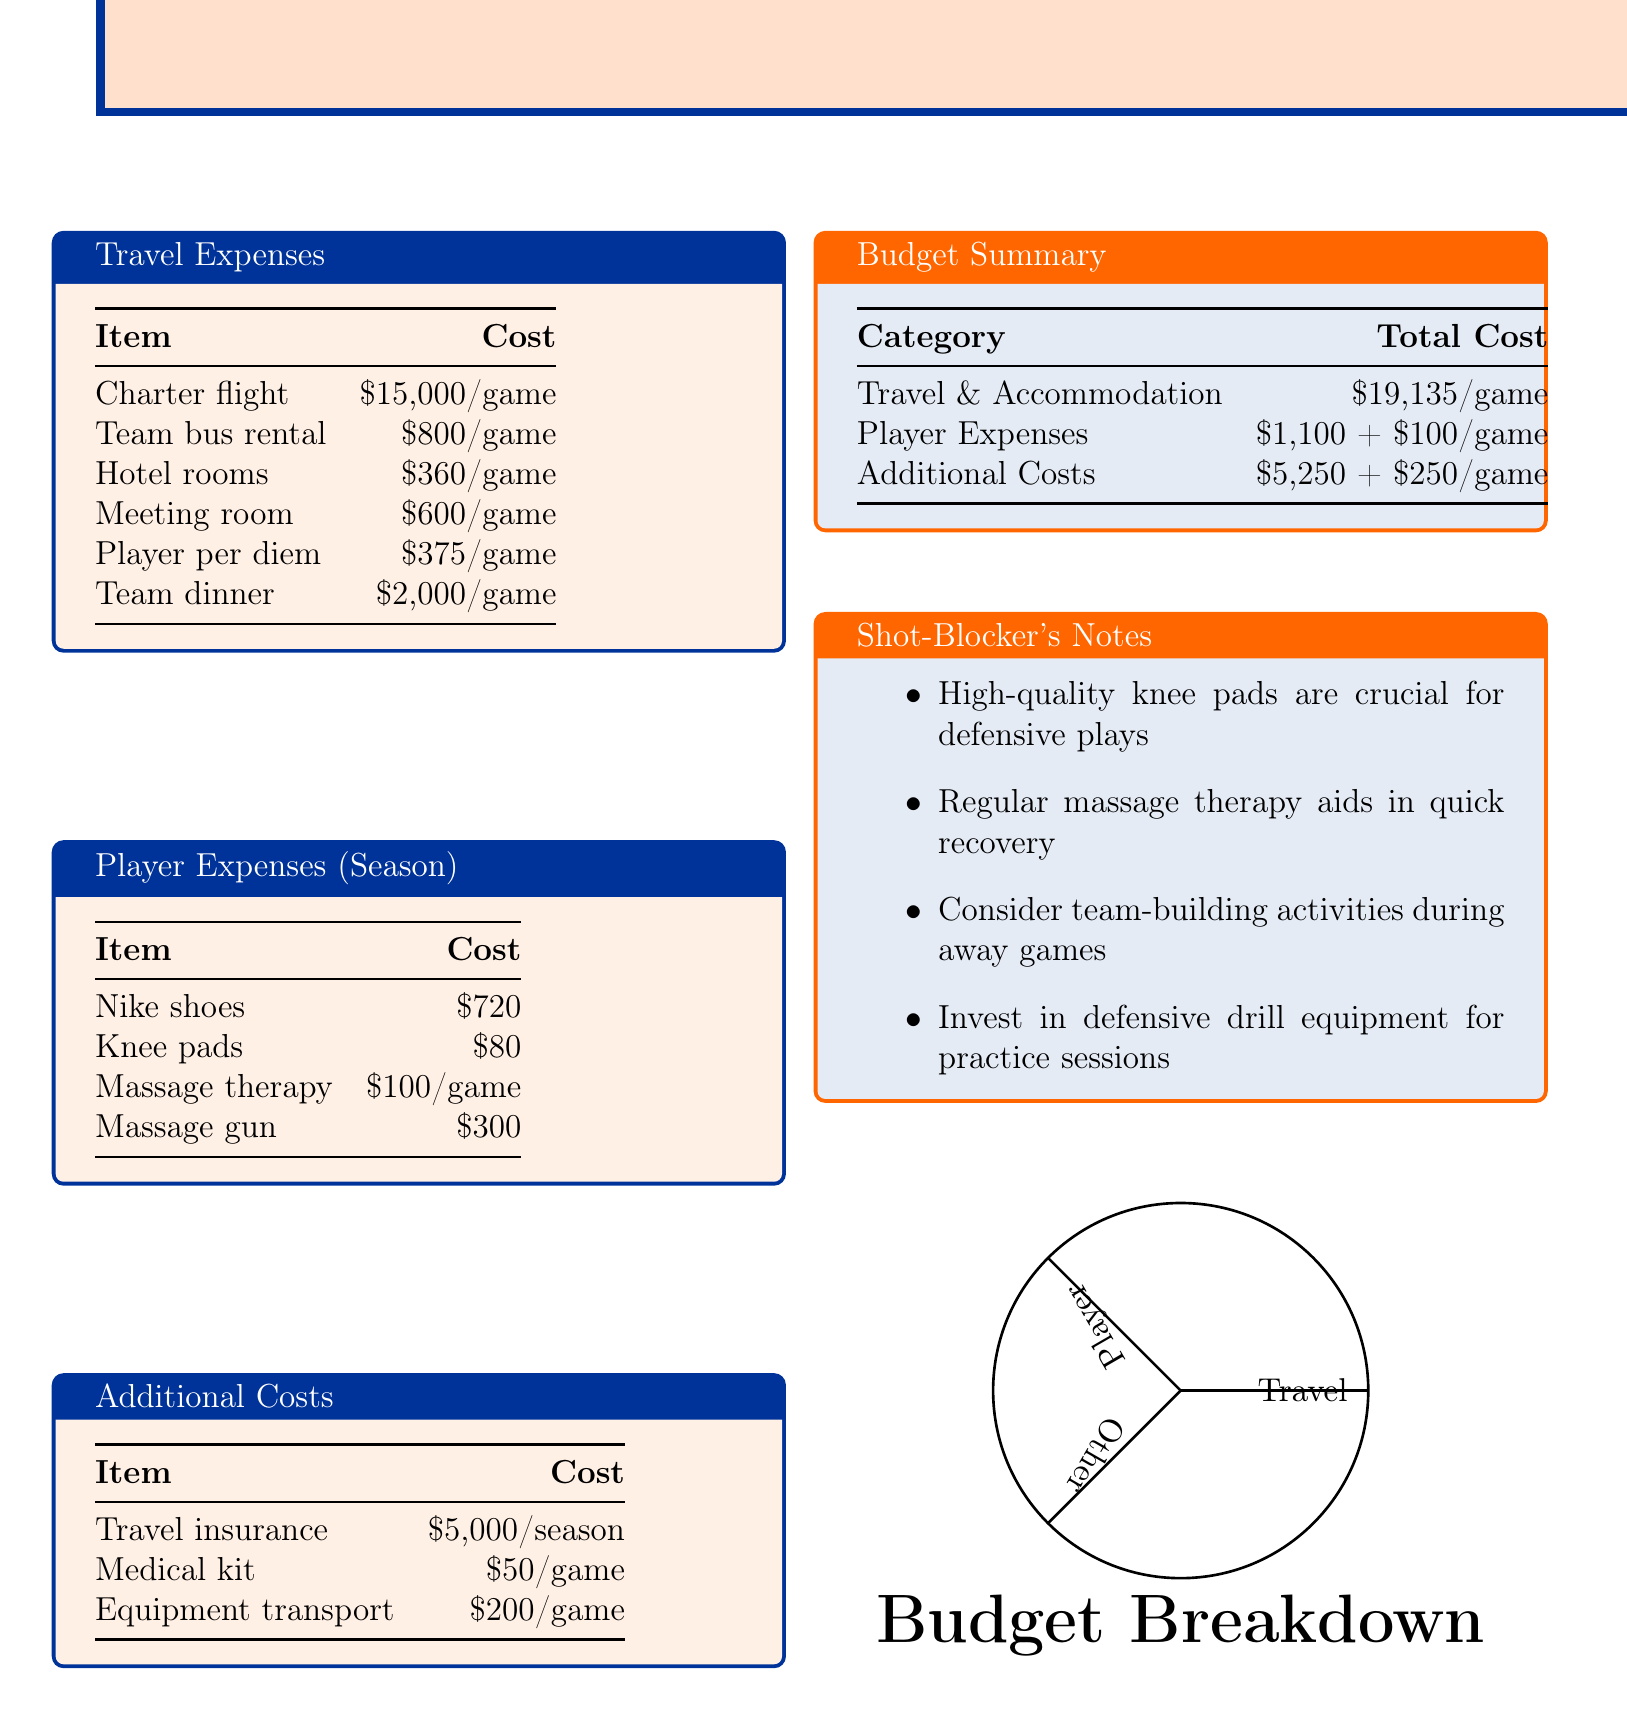what is the cost of a charter flight? The cost of a charter flight during away games is specified in the travel expenses section as $15,000 per game.
Answer: $15,000/game how much is the team bus rental? The document states that the team bus rental costs $800 for each game, as noted in the travel expenses.
Answer: $800/game what is the total cost for travel and accommodation per game? Total cost for travel and accommodation can be found in the budget summary section, which adds up all relevant expenses to $19,135 per game.
Answer: $19,135/game how much do players receive for per diem? The per diem amount for players during away games is listed as $375.
Answer: $375/game what is the cost of travel insurance for the season? The travel insurance cost for the season is indicated in the additional costs section as $5,000.
Answer: $5,000/season what is the total cost for player expenses per game? Total player expenses, including both fixed and variable costs per game, is summarized in the document as $1,100 plus $100 for each game.
Answer: $1,100 + $100/game how much is allocated for team dinner? The budget allocates $2,000 for team dinner during away games, as per the travel expenses breakdown.
Answer: $2,000/game what are high-quality knee pads crucial for? As mentioned in the shot-blocker's notes, high-quality knee pads are crucial for defensive plays.
Answer: Defensive plays what is the cost of massage therapy per game? The cost for massage therapy is detailed in the player expenses section as $100 for each game.
Answer: $100/game 